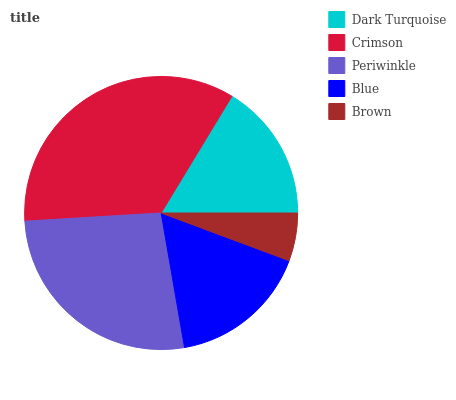Is Brown the minimum?
Answer yes or no. Yes. Is Crimson the maximum?
Answer yes or no. Yes. Is Periwinkle the minimum?
Answer yes or no. No. Is Periwinkle the maximum?
Answer yes or no. No. Is Crimson greater than Periwinkle?
Answer yes or no. Yes. Is Periwinkle less than Crimson?
Answer yes or no. Yes. Is Periwinkle greater than Crimson?
Answer yes or no. No. Is Crimson less than Periwinkle?
Answer yes or no. No. Is Blue the high median?
Answer yes or no. Yes. Is Blue the low median?
Answer yes or no. Yes. Is Periwinkle the high median?
Answer yes or no. No. Is Brown the low median?
Answer yes or no. No. 